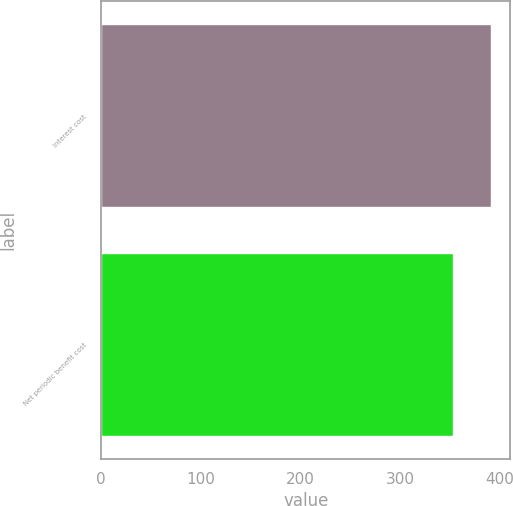<chart> <loc_0><loc_0><loc_500><loc_500><bar_chart><fcel>Interest cost<fcel>Net periodic benefit cost<nl><fcel>391<fcel>353<nl></chart> 